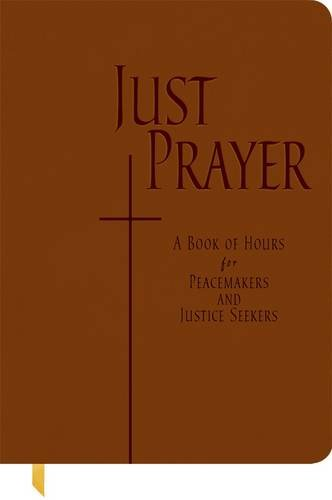Is this christianity book? Yes, it is indeed a Christian book that enriches religious practice with a focus on peace and justice, reflecting Christian values and teachings. 